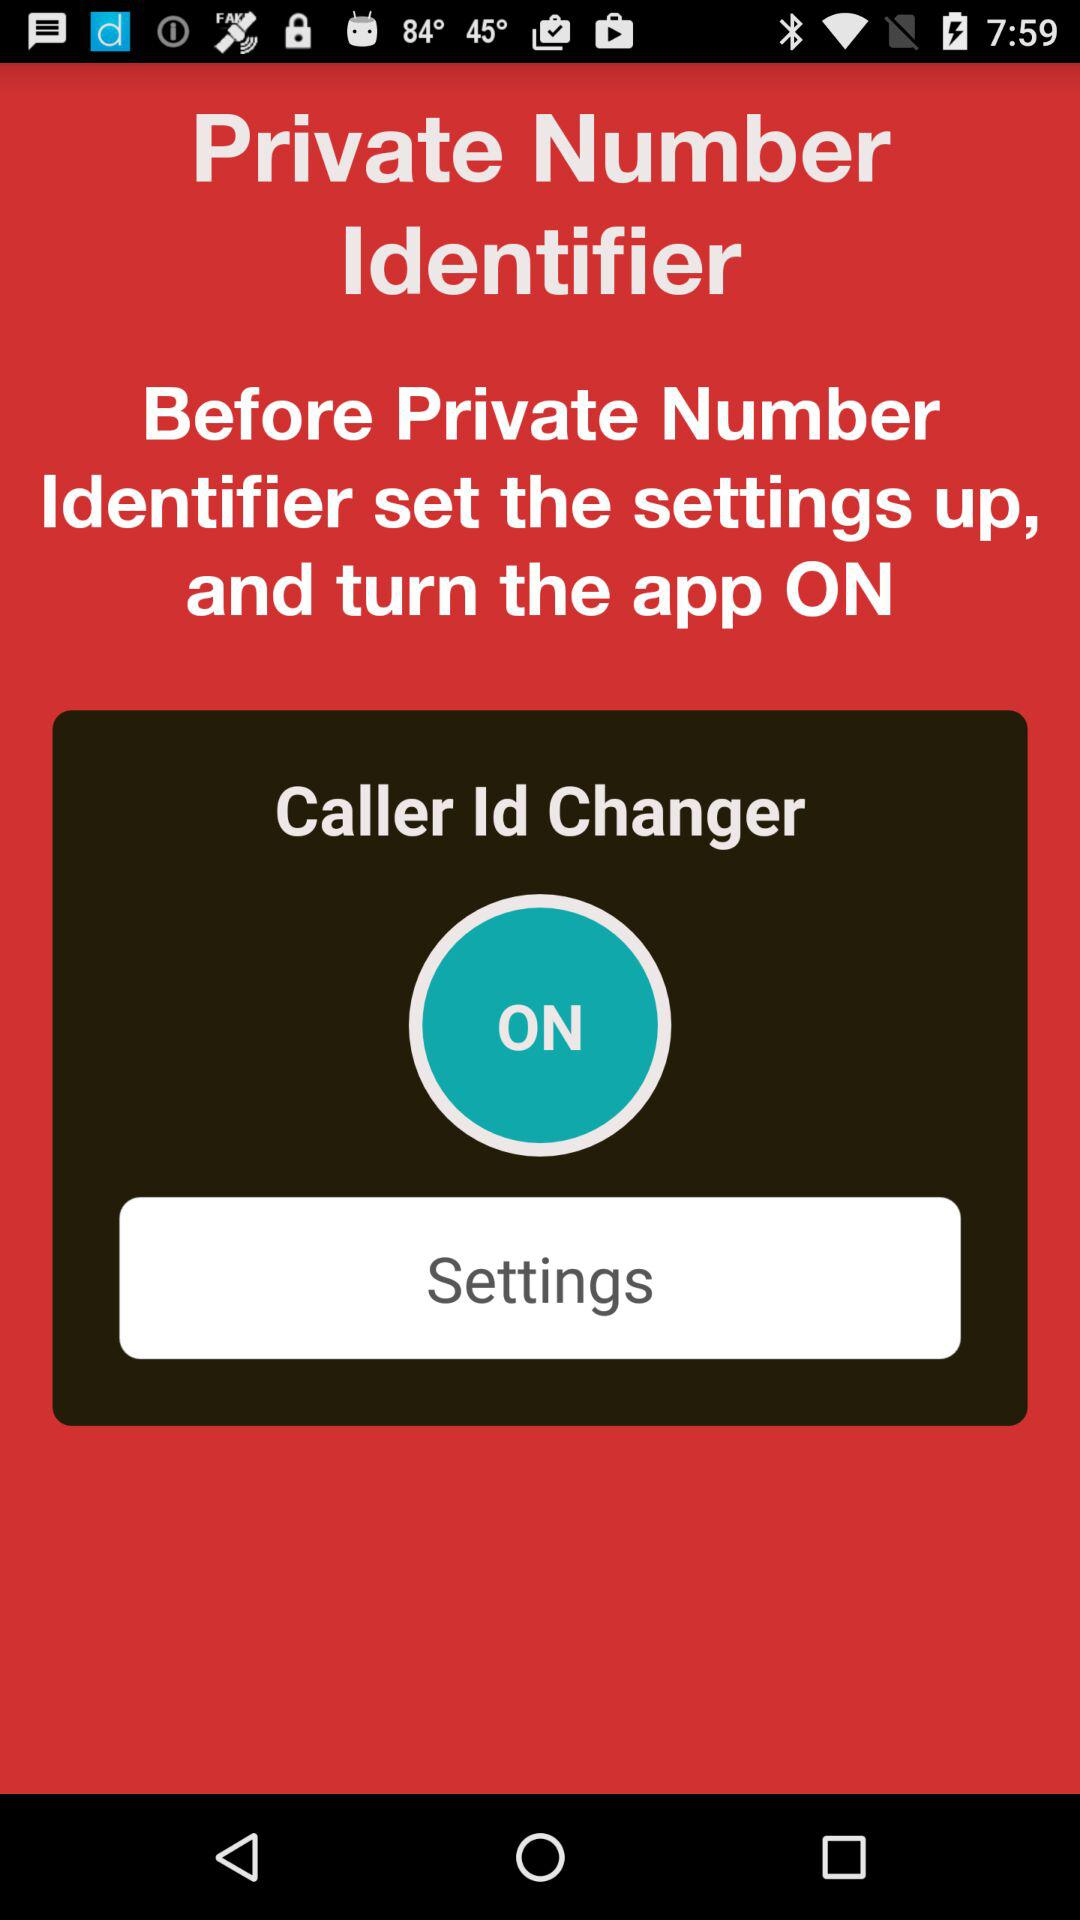What is the status of the "Caller Id Changer"? The status is "on". 